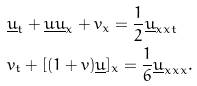<formula> <loc_0><loc_0><loc_500><loc_500>& \underline { u } _ { t } + \underline { u } \underline { u } _ { x } + v _ { x } = \frac { 1 } { 2 } \underline { u } _ { x x t } \\ & v _ { t } + [ ( 1 + v ) \underline { u } ] _ { x } = \frac { 1 } { 6 } \underline { u } _ { x x x } .</formula> 